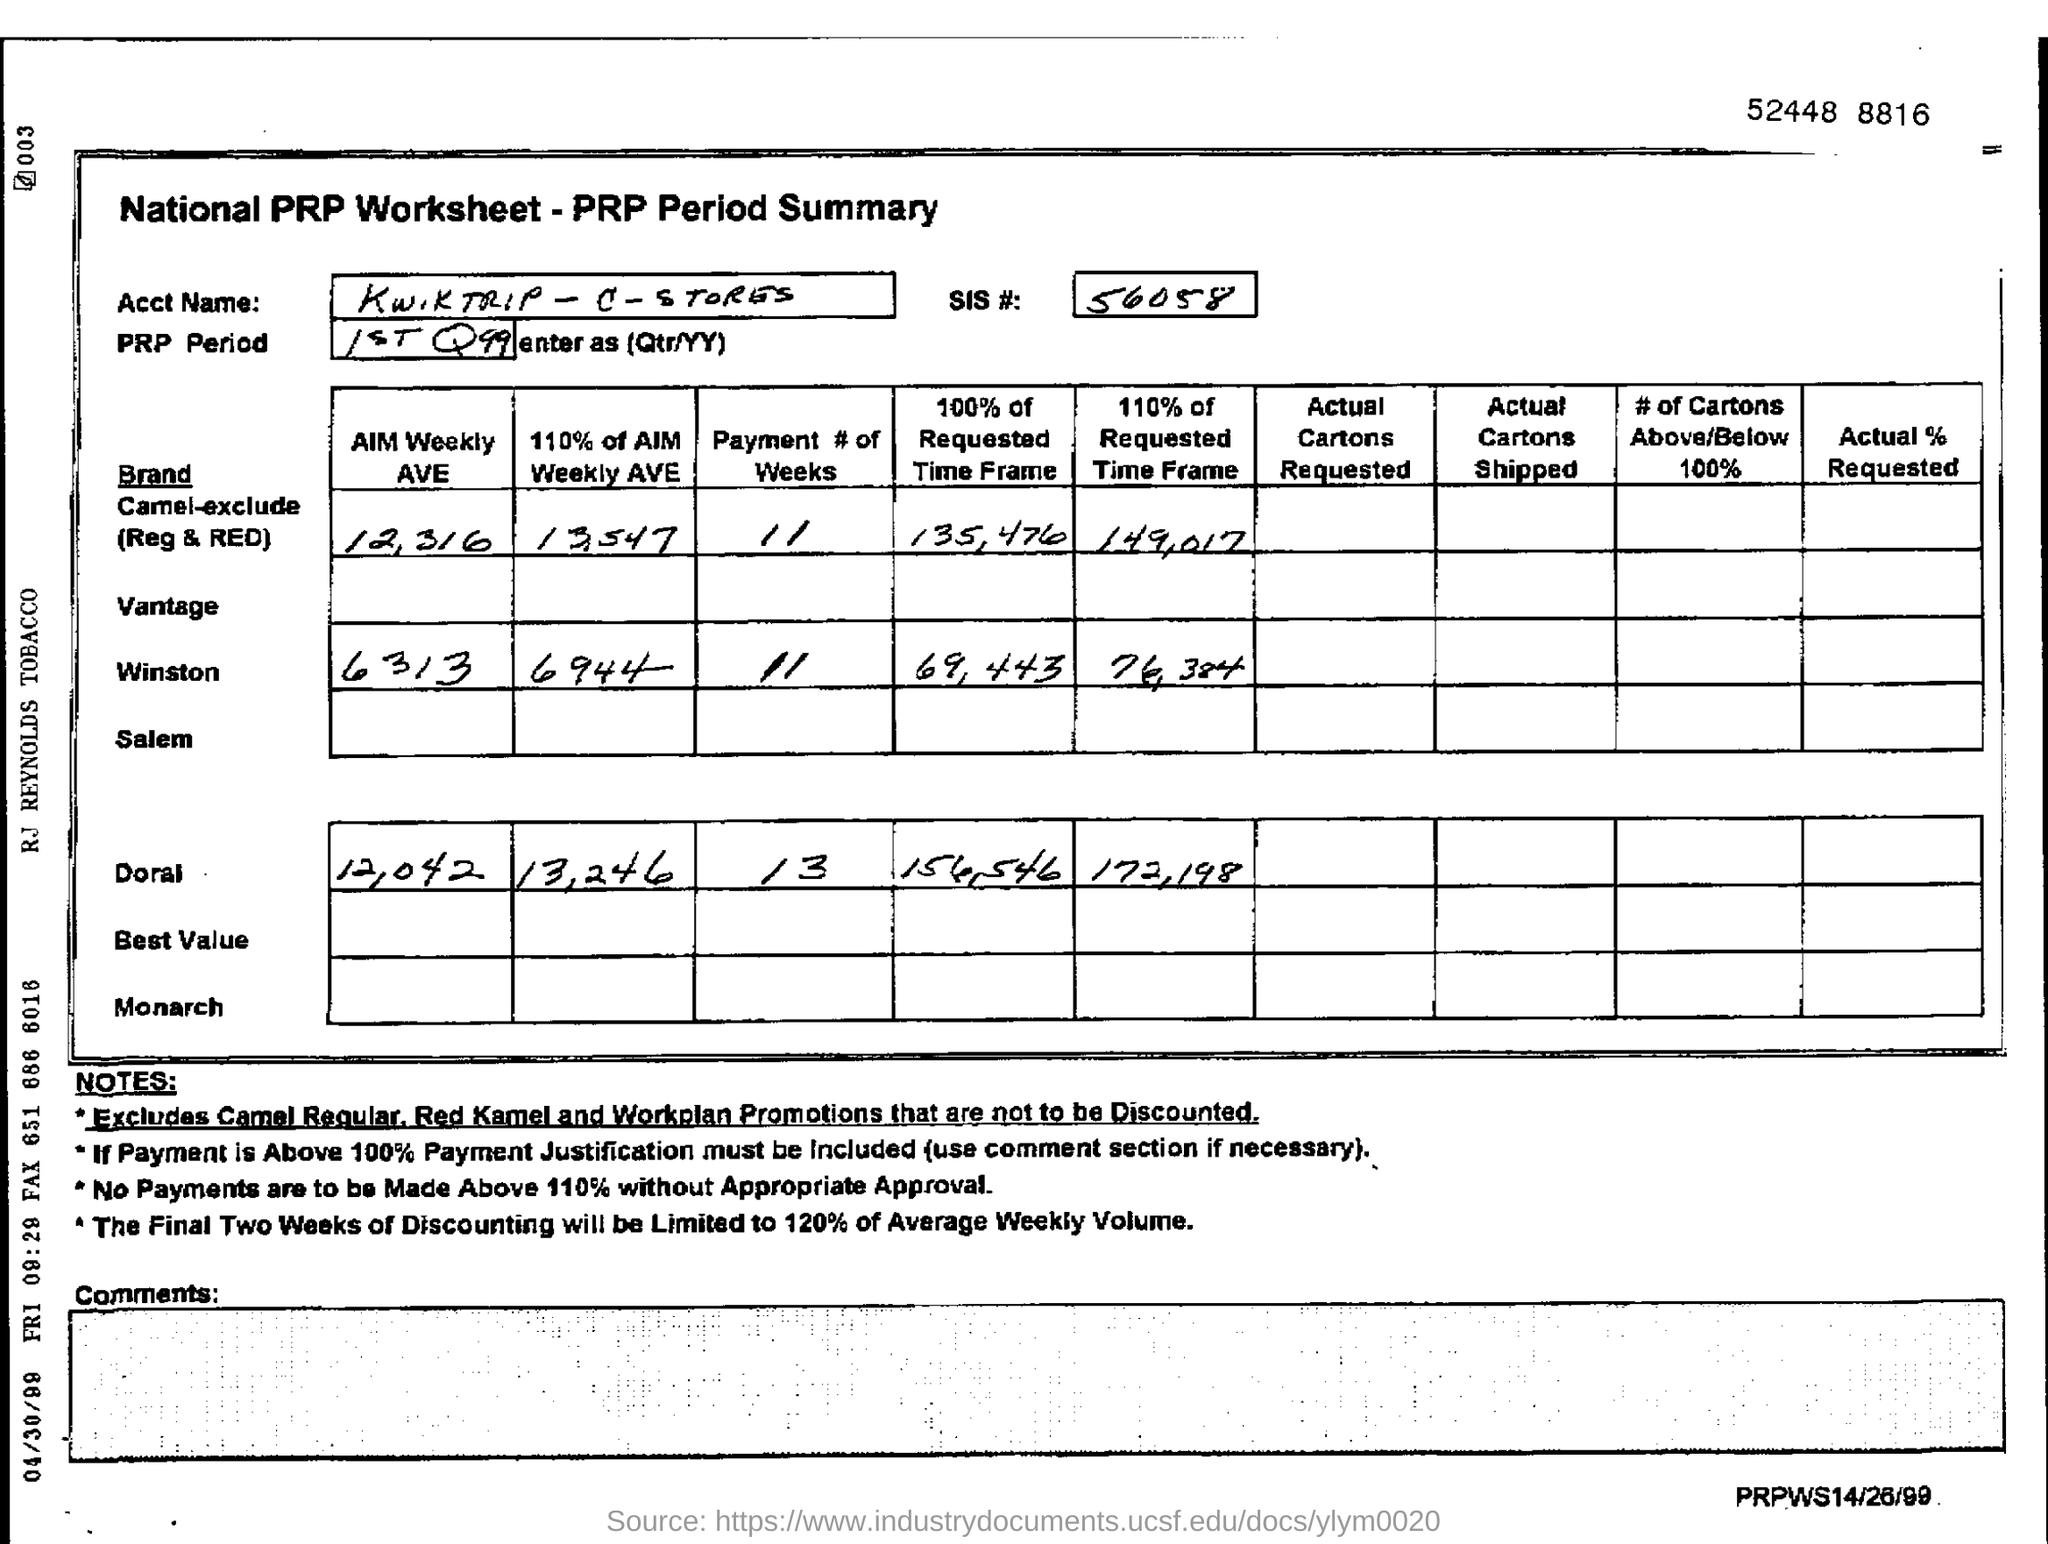What is the SIS# mentioned in the form?
Offer a terse response. 56058. What is the SIS #?
Ensure brevity in your answer.  56058. What is the AIM Weekly AVE of Winston?
Your answer should be very brief. 6313. 